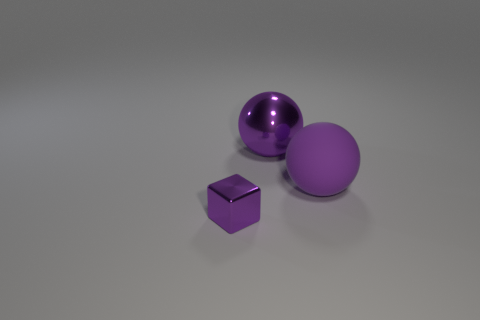Is there any other thing that has the same size as the shiny block?
Ensure brevity in your answer.  No. The other ball that is the same color as the large matte ball is what size?
Ensure brevity in your answer.  Large. What number of purple things are both in front of the matte thing and behind the cube?
Provide a succinct answer. 0. What number of other things are there of the same size as the rubber object?
Give a very brief answer. 1. Are there an equal number of large purple metallic things left of the cube and yellow metallic balls?
Offer a very short reply. Yes. Does the metallic object that is in front of the matte object have the same color as the metallic thing that is behind the small thing?
Your answer should be compact. Yes. There is a object that is both in front of the big purple metal thing and behind the metallic cube; what material is it?
Give a very brief answer. Rubber. The matte ball is what color?
Offer a terse response. Purple. What number of other objects are there of the same shape as the small purple shiny thing?
Your response must be concise. 0. Are there the same number of tiny purple shiny objects that are right of the small purple cube and things that are left of the matte ball?
Your answer should be very brief. No. 